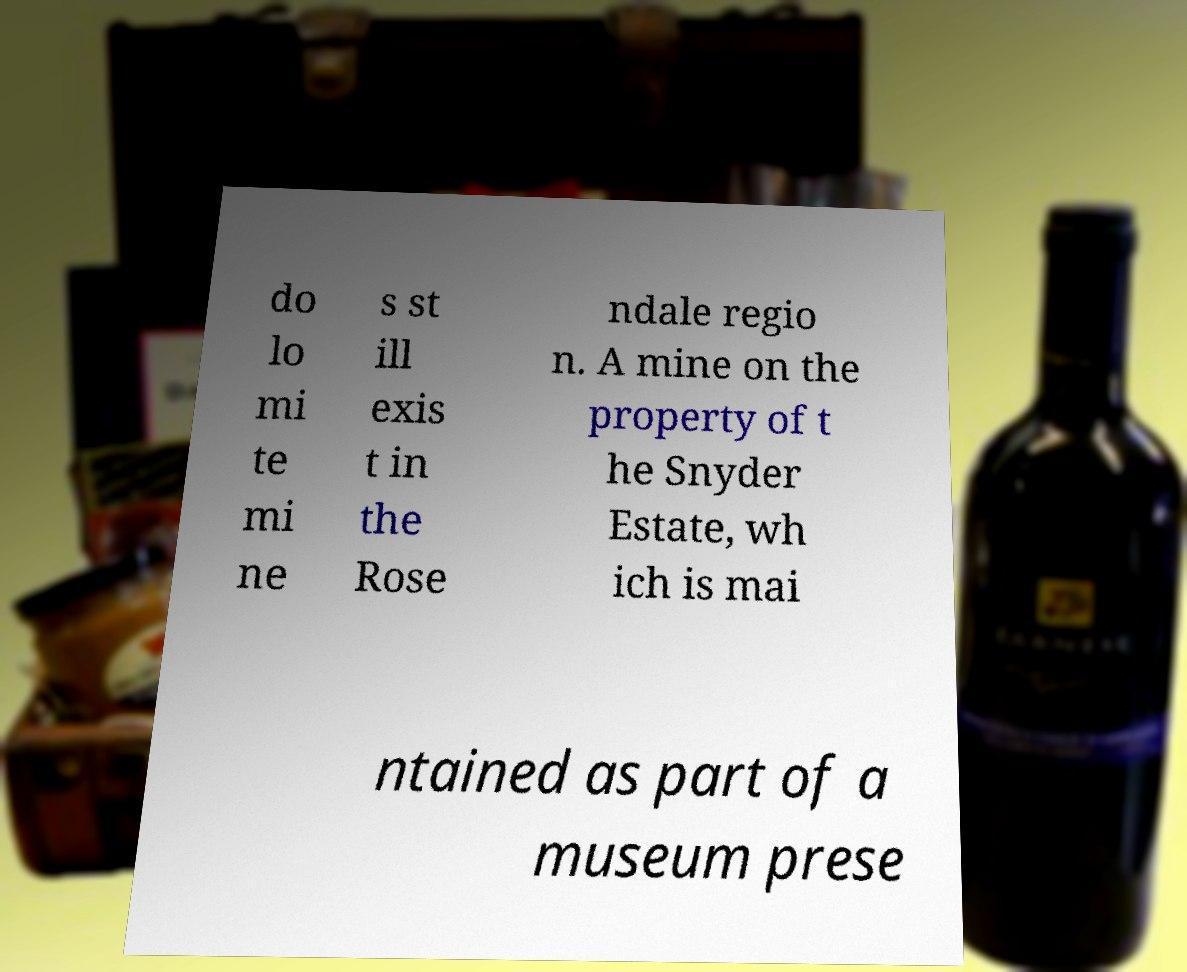Please identify and transcribe the text found in this image. do lo mi te mi ne s st ill exis t in the Rose ndale regio n. A mine on the property of t he Snyder Estate, wh ich is mai ntained as part of a museum prese 